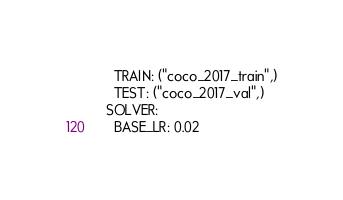Convert code to text. <code><loc_0><loc_0><loc_500><loc_500><_YAML_>  TRAIN: ("coco_2017_train",)
  TEST: ("coco_2017_val",)
SOLVER:
  BASE_LR: 0.02
</code> 